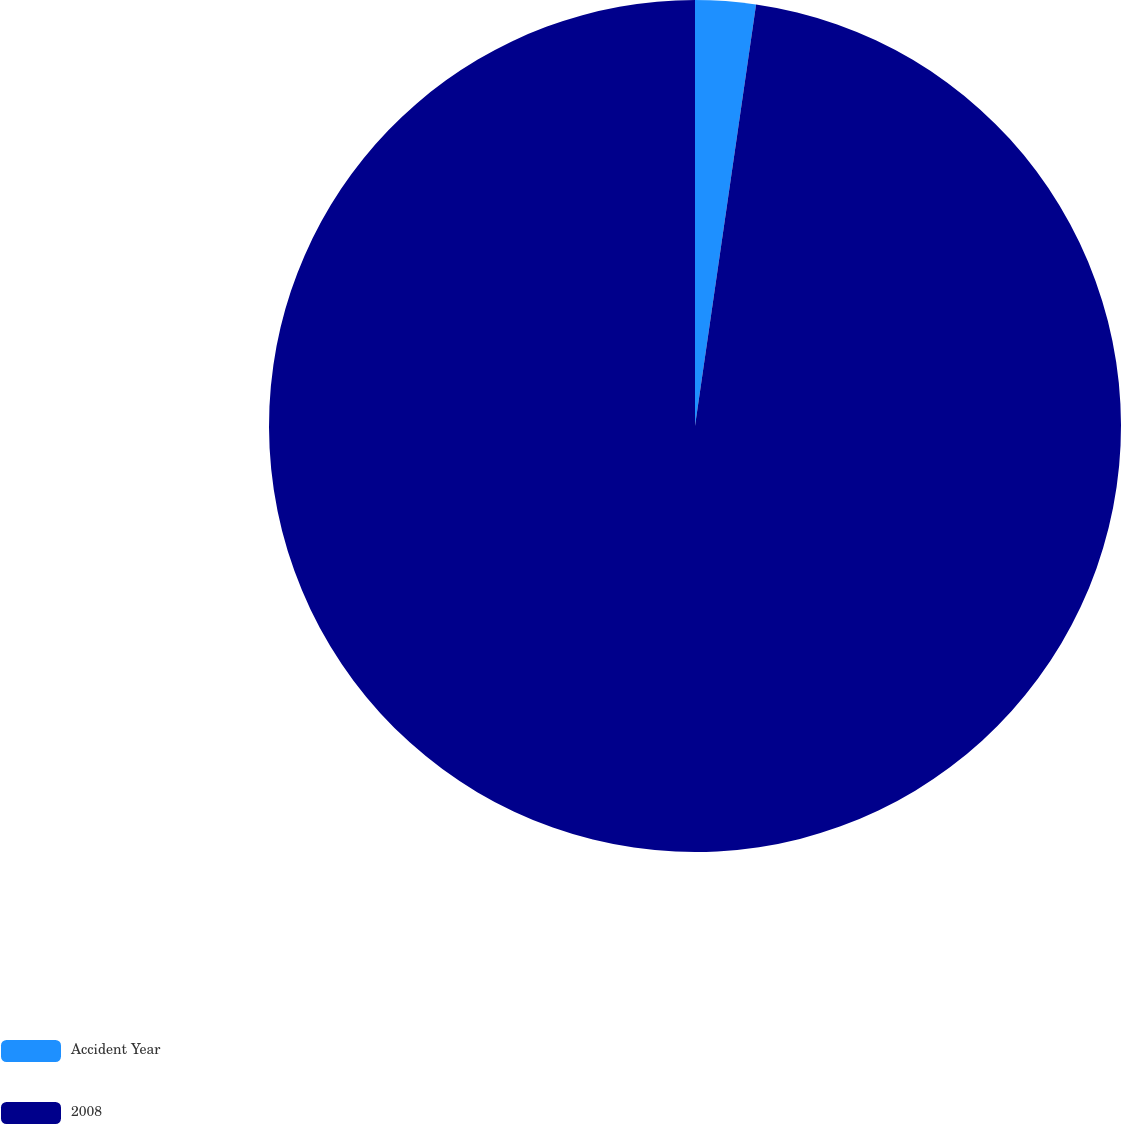<chart> <loc_0><loc_0><loc_500><loc_500><pie_chart><fcel>Accident Year<fcel>2008<nl><fcel>2.29%<fcel>97.71%<nl></chart> 